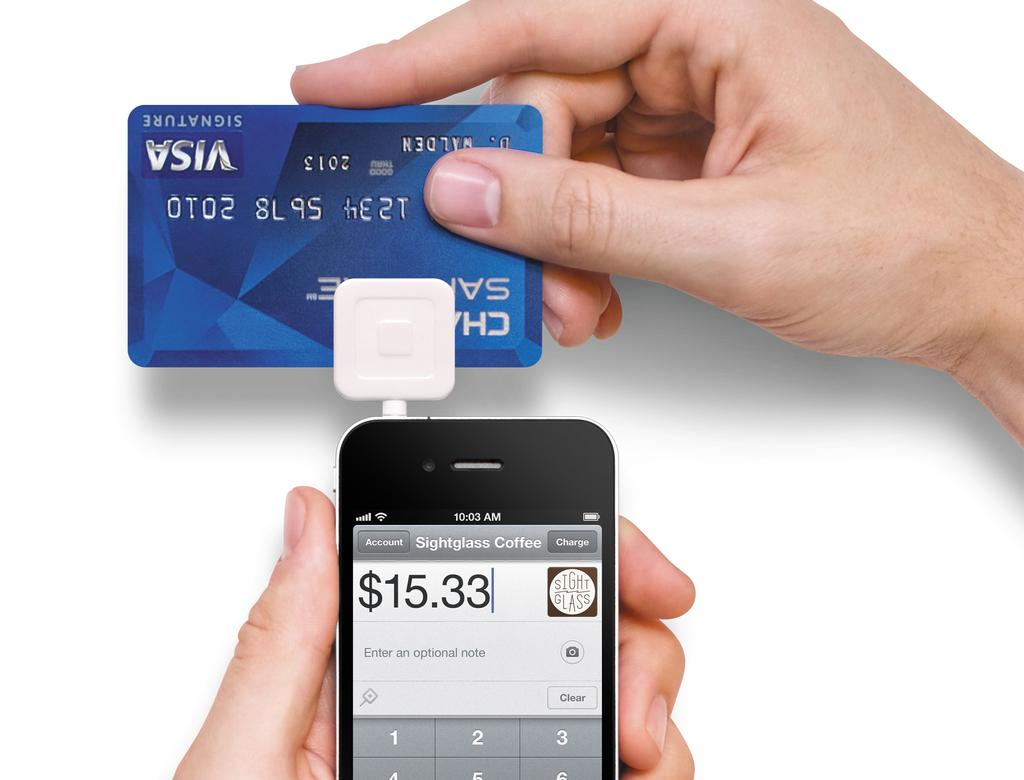<image>
Summarize the visual content of the image. Someone swipes their Visa card through their phone for an amount of $15.33. 